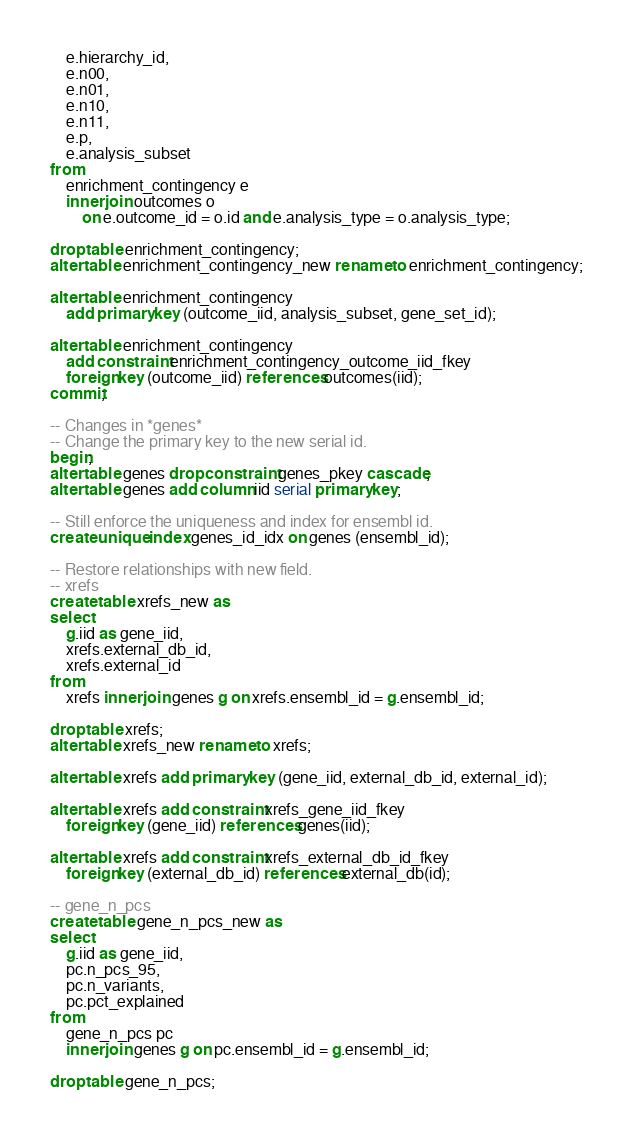<code> <loc_0><loc_0><loc_500><loc_500><_SQL_>    e.hierarchy_id,
    e.n00,
    e.n01,
    e.n10,
    e.n11,
    e.p,
    e.analysis_subset
from
    enrichment_contingency e
    inner join outcomes o
        on e.outcome_id = o.id and e.analysis_type = o.analysis_type;

drop table enrichment_contingency;
alter table enrichment_contingency_new rename to enrichment_contingency;

alter table enrichment_contingency
    add primary key (outcome_iid, analysis_subset, gene_set_id);

alter table enrichment_contingency
    add constraint enrichment_contingency_outcome_iid_fkey
    foreign key (outcome_iid) references outcomes(iid);
commit;

-- Changes in *genes*
-- Change the primary key to the new serial id.
begin;
alter table genes drop constraint genes_pkey cascade;
alter table genes add column iid serial primary key;

-- Still enforce the uniqueness and index for ensembl id.
create unique index genes_id_idx on genes (ensembl_id);

-- Restore relationships with new field.
-- xrefs
create table xrefs_new as
select
    g.iid as gene_iid,
    xrefs.external_db_id,
    xrefs.external_id
from
    xrefs inner join genes g on xrefs.ensembl_id = g.ensembl_id;

drop table xrefs;
alter table xrefs_new rename to xrefs;

alter table xrefs add primary key (gene_iid, external_db_id, external_id);

alter table xrefs add constraint xrefs_gene_iid_fkey
    foreign key (gene_iid) references genes(iid);

alter table xrefs add constraint xrefs_external_db_id_fkey
    foreign key (external_db_id) references external_db(id);

-- gene_n_pcs
create table gene_n_pcs_new as
select
    g.iid as gene_iid,
    pc.n_pcs_95,
    pc.n_variants,
    pc.pct_explained
from
    gene_n_pcs pc
    inner join genes g on pc.ensembl_id = g.ensembl_id;

drop table gene_n_pcs;</code> 